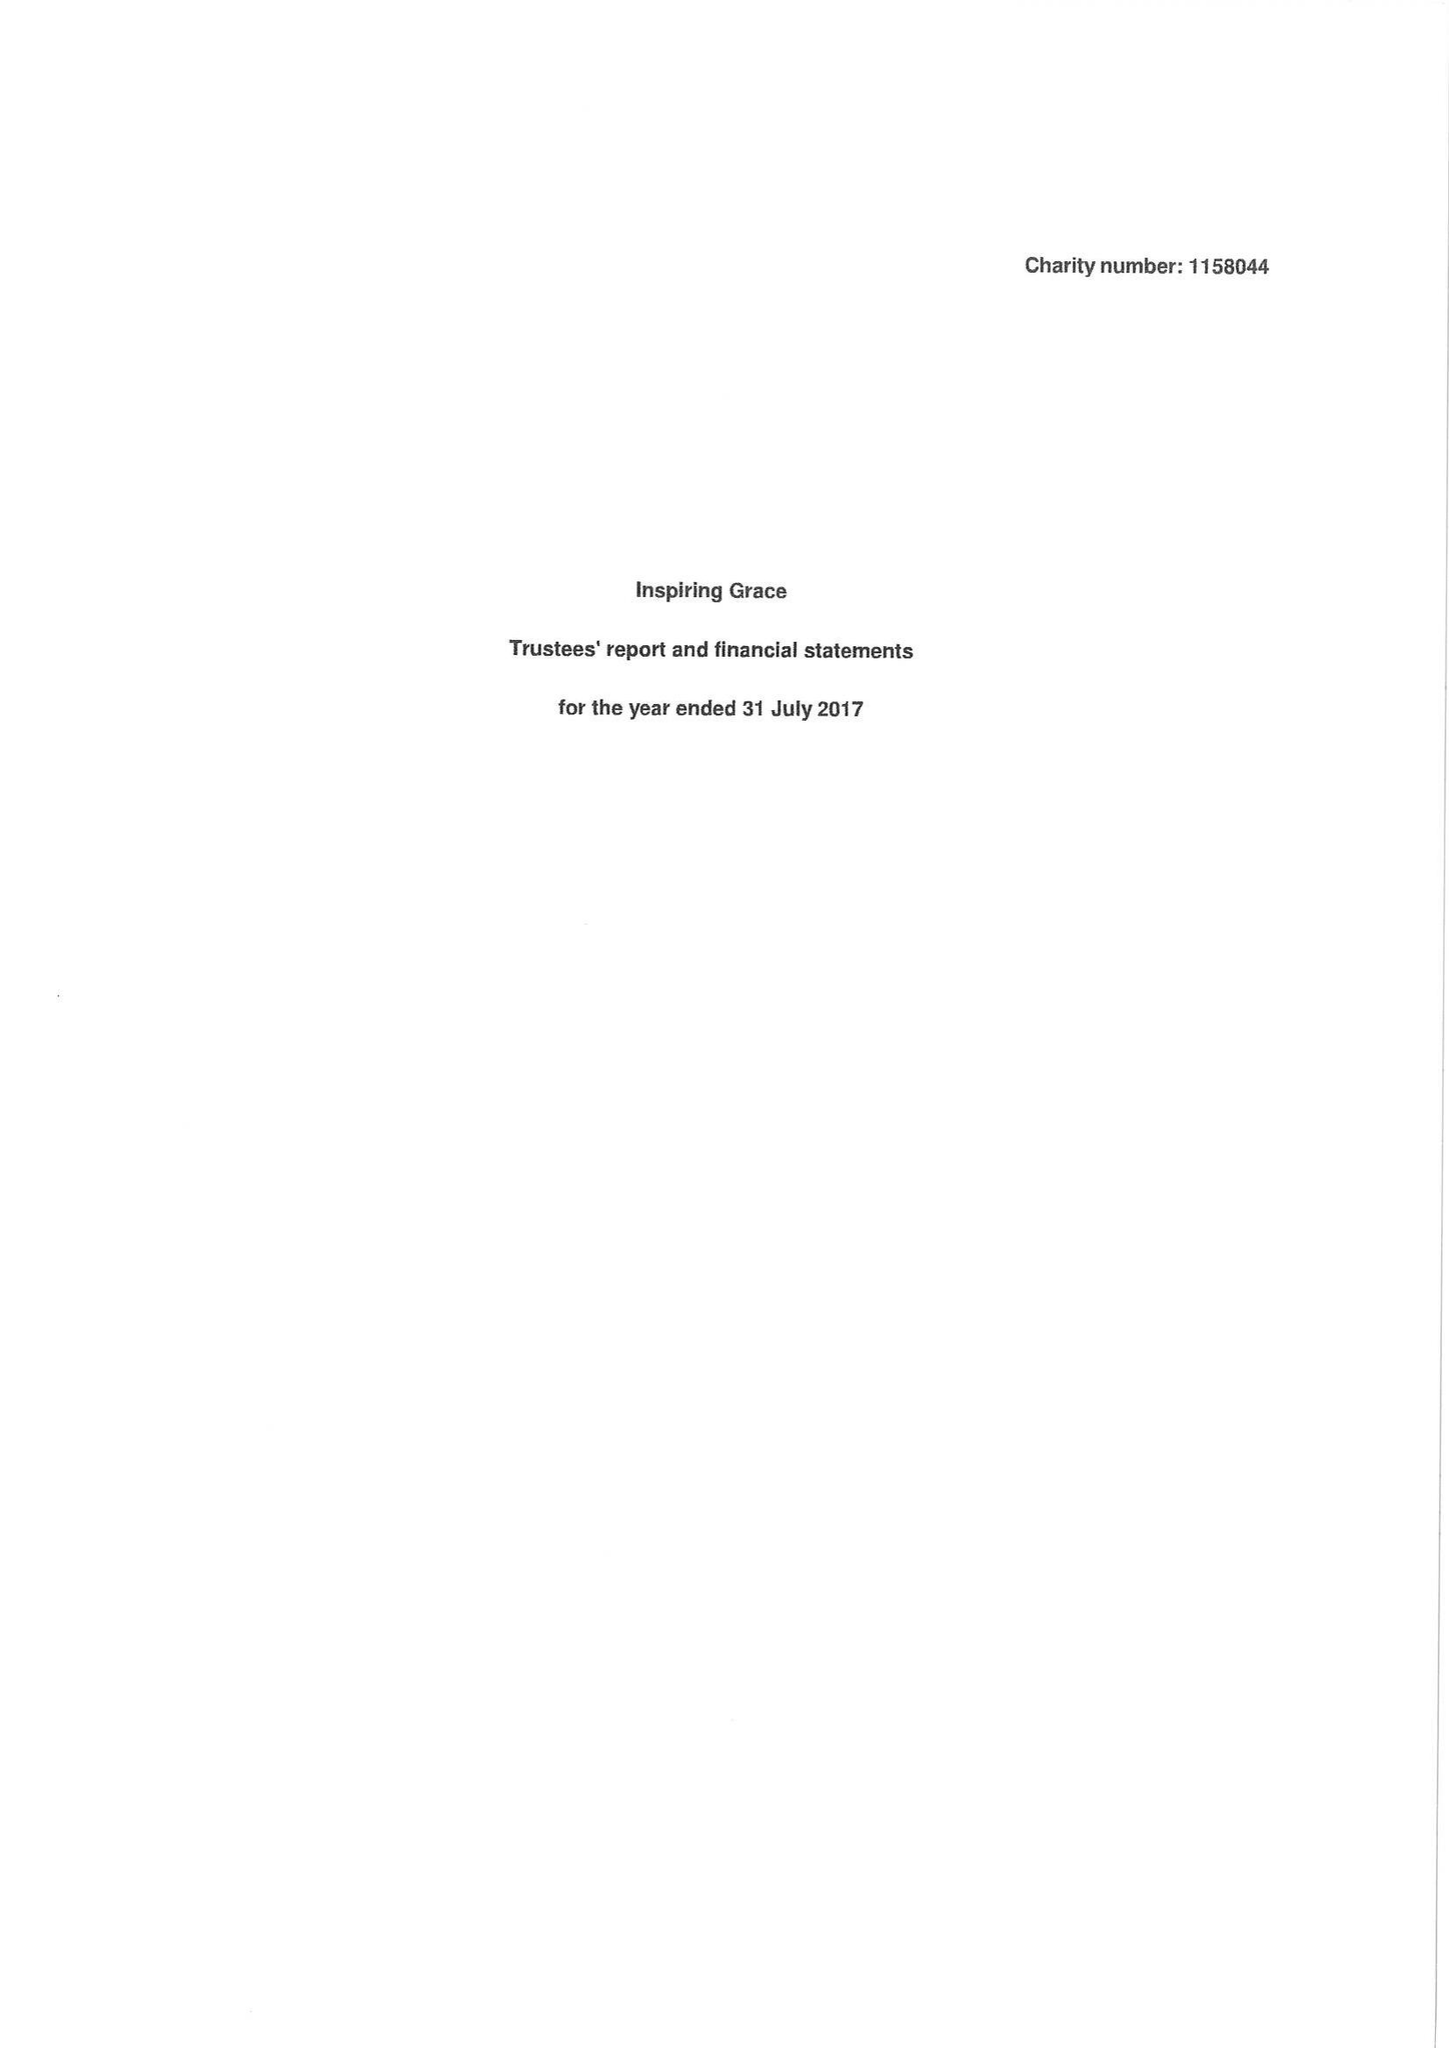What is the value for the address__post_town?
Answer the question using a single word or phrase. NELSON 